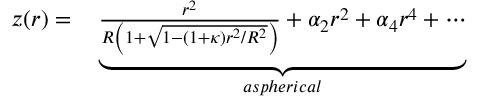Convert formula to latex. <formula><loc_0><loc_0><loc_500><loc_500>\begin{array} { r l } { z ( r ) = } & \underbrace { \frac { r ^ { 2 } } { R \left ( 1 + \sqrt { 1 - ( 1 + \kappa ) r ^ { 2 } / R ^ { 2 } } \right ) } + \alpha _ { 2 } r ^ { 2 } + \alpha _ { 4 } r ^ { 4 } + \cdots } _ { a s p h e r i c a l } } \end{array}</formula> 